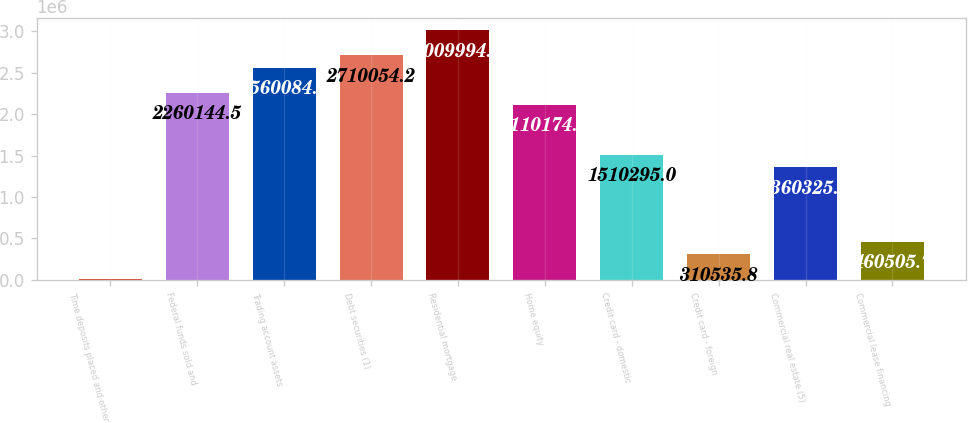Convert chart to OTSL. <chart><loc_0><loc_0><loc_500><loc_500><bar_chart><fcel>Time deposits placed and other<fcel>Federal funds sold and<fcel>Trading account assets<fcel>Debt securities (1)<fcel>Residential mortgage<fcel>Home equity<fcel>Credit card - domestic<fcel>Credit card - foreign<fcel>Commercial real estate (5)<fcel>Commercial lease financing<nl><fcel>10596<fcel>2.26014e+06<fcel>2.56008e+06<fcel>2.71005e+06<fcel>3.00999e+06<fcel>2.11017e+06<fcel>1.5103e+06<fcel>310536<fcel>1.36033e+06<fcel>460506<nl></chart> 